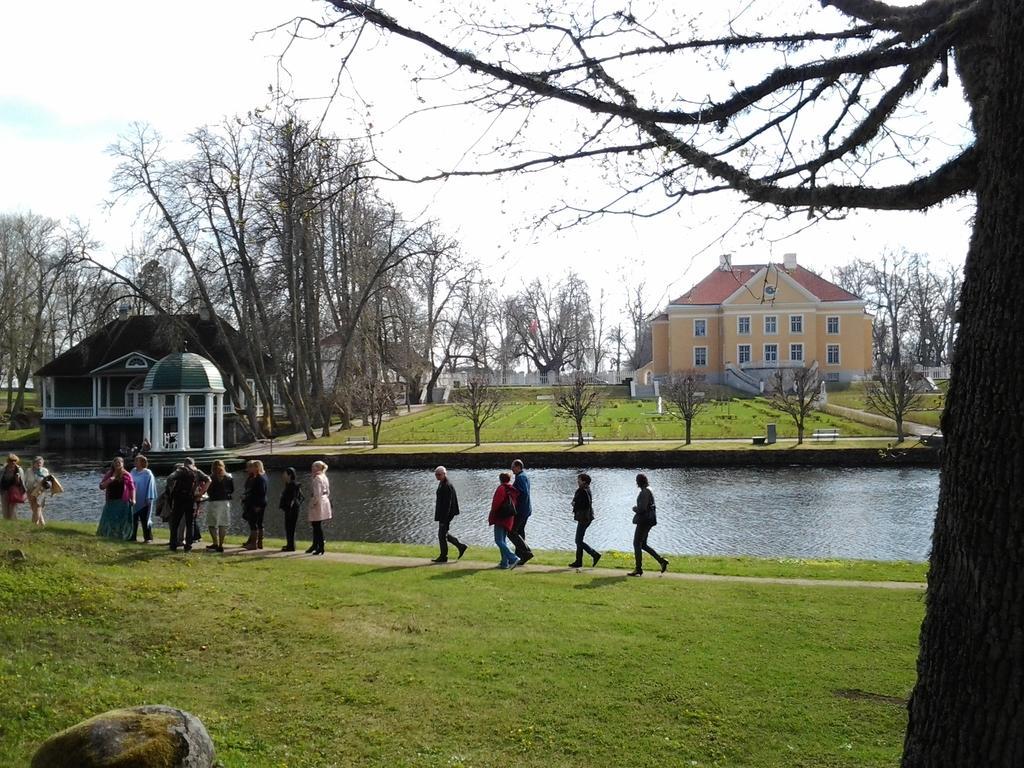Could you give a brief overview of what you see in this image? In this picture there are people those who are standing in series in the image and there is grassland at the bottom side of the image and there is water in the center of the image and there are houses and trees in the background area of the image and there is a tree on the right side of the image. 